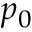Convert formula to latex. <formula><loc_0><loc_0><loc_500><loc_500>p _ { 0 }</formula> 